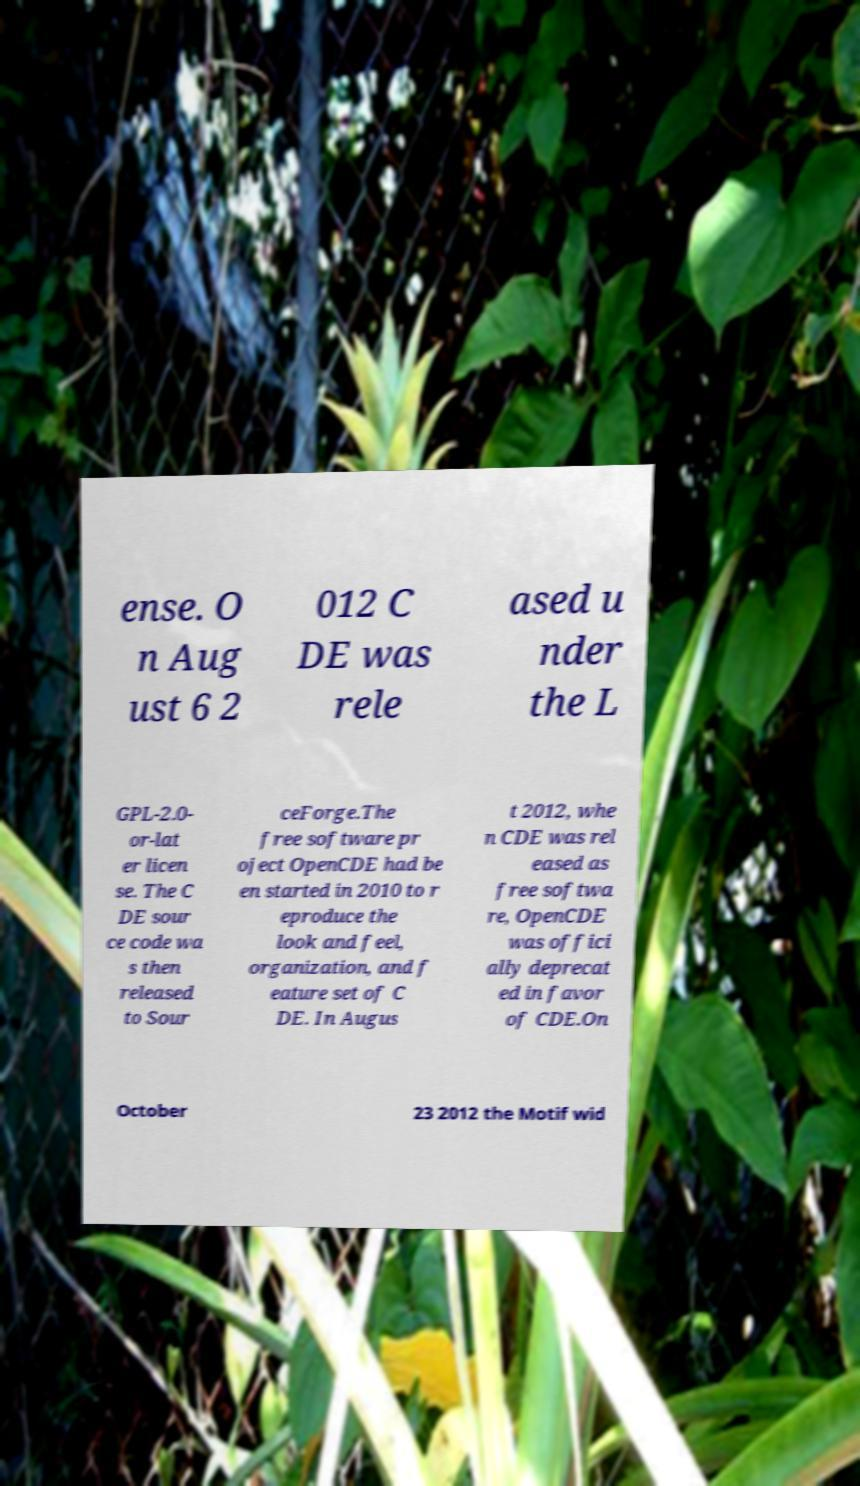I need the written content from this picture converted into text. Can you do that? ense. O n Aug ust 6 2 012 C DE was rele ased u nder the L GPL-2.0- or-lat er licen se. The C DE sour ce code wa s then released to Sour ceForge.The free software pr oject OpenCDE had be en started in 2010 to r eproduce the look and feel, organization, and f eature set of C DE. In Augus t 2012, whe n CDE was rel eased as free softwa re, OpenCDE was offici ally deprecat ed in favor of CDE.On October 23 2012 the Motif wid 